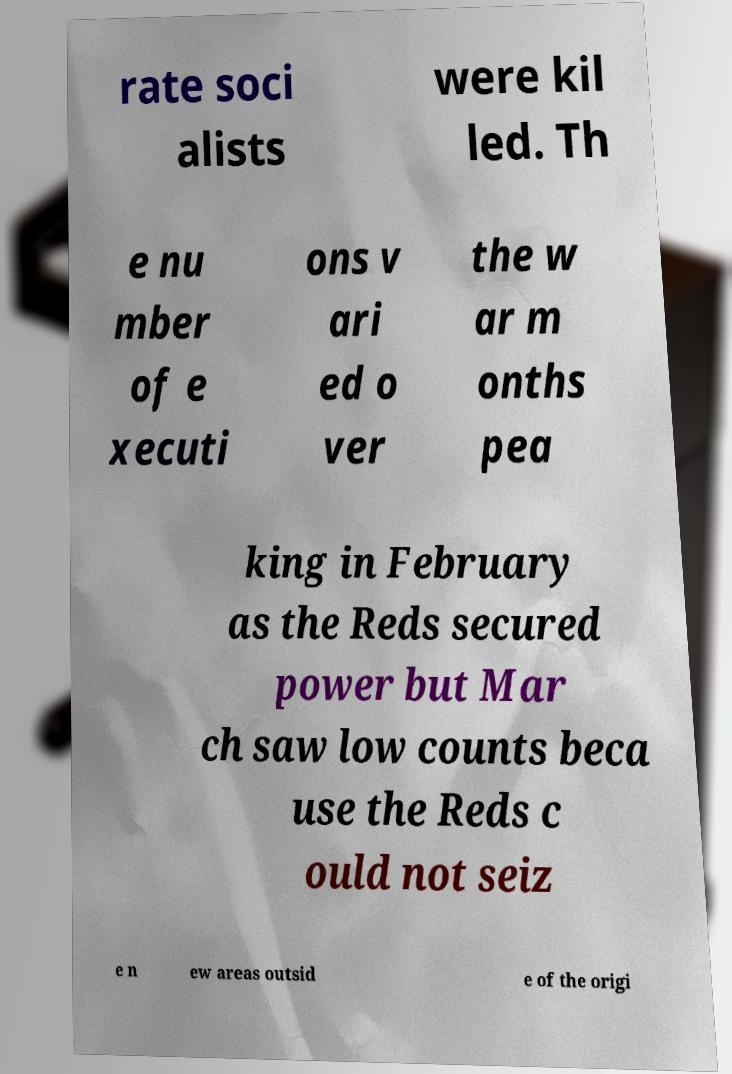Can you accurately transcribe the text from the provided image for me? rate soci alists were kil led. Th e nu mber of e xecuti ons v ari ed o ver the w ar m onths pea king in February as the Reds secured power but Mar ch saw low counts beca use the Reds c ould not seiz e n ew areas outsid e of the origi 